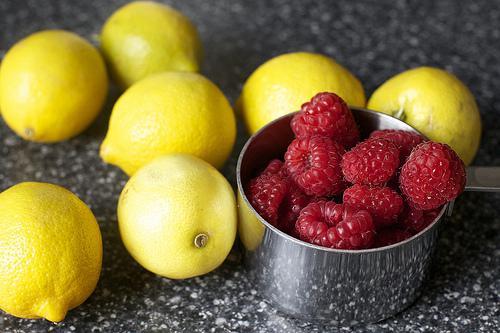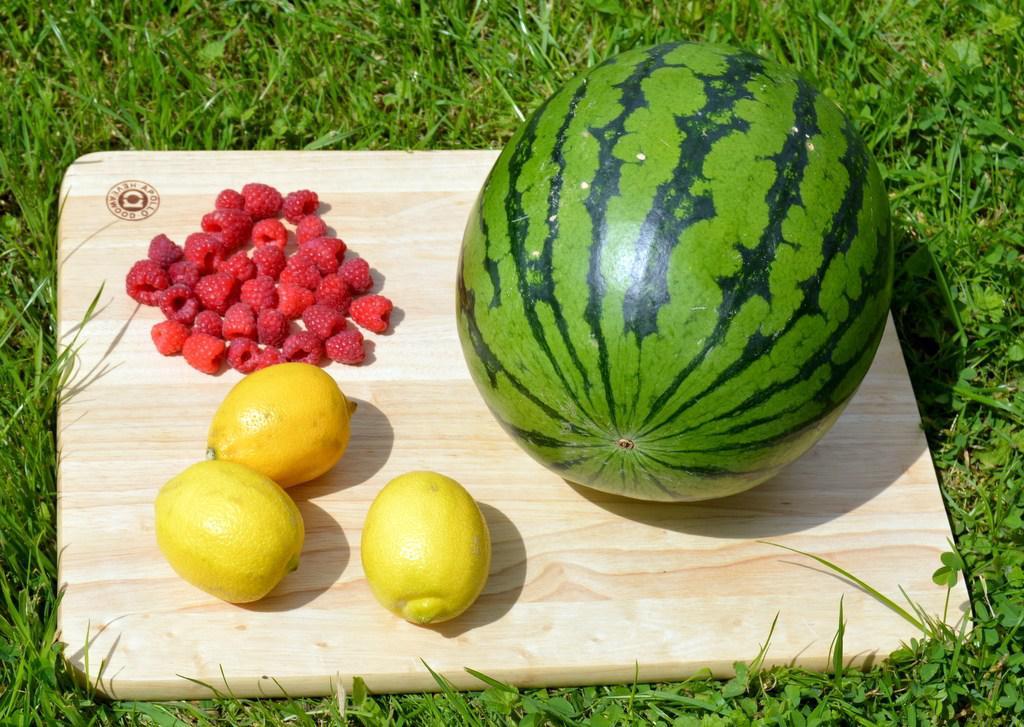The first image is the image on the left, the second image is the image on the right. Evaluate the accuracy of this statement regarding the images: "There is exactly one straw in a drink.". Is it true? Answer yes or no. No. The first image is the image on the left, the second image is the image on the right. Assess this claim about the two images: "In one image, one or more fruit drinks is garnished with raspberries, lemon and mint, and has a straw extended from the top, while a second image shows cut watermelon.". Correct or not? Answer yes or no. No. 